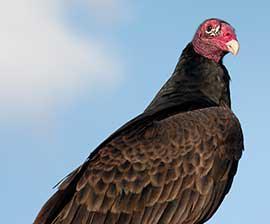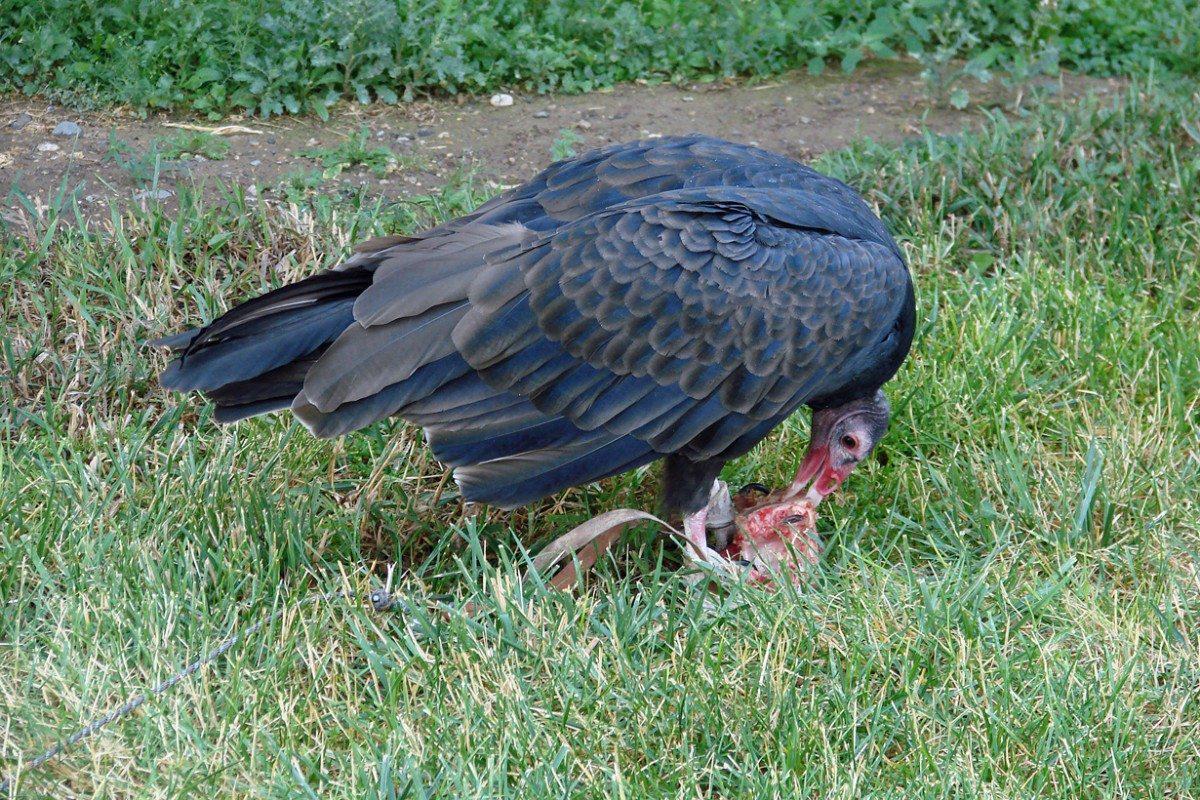The first image is the image on the left, the second image is the image on the right. For the images displayed, is the sentence "The right image includes two vultures standing face-to-face." factually correct? Answer yes or no. No. The first image is the image on the left, the second image is the image on the right. Assess this claim about the two images: "In the image to the right, two vultures rest, wings closed.". Correct or not? Answer yes or no. No. 